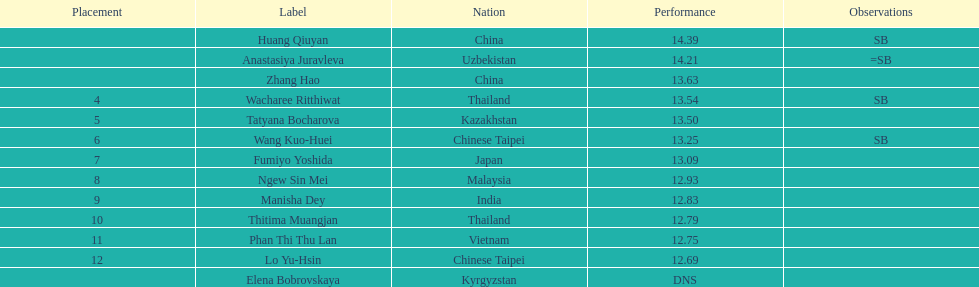Write the full table. {'header': ['Placement', 'Label', 'Nation', 'Performance', 'Observations'], 'rows': [['', 'Huang Qiuyan', 'China', '14.39', 'SB'], ['', 'Anastasiya Juravleva', 'Uzbekistan', '14.21', '=SB'], ['', 'Zhang Hao', 'China', '13.63', ''], ['4', 'Wacharee Ritthiwat', 'Thailand', '13.54', 'SB'], ['5', 'Tatyana Bocharova', 'Kazakhstan', '13.50', ''], ['6', 'Wang Kuo-Huei', 'Chinese Taipei', '13.25', 'SB'], ['7', 'Fumiyo Yoshida', 'Japan', '13.09', ''], ['8', 'Ngew Sin Mei', 'Malaysia', '12.93', ''], ['9', 'Manisha Dey', 'India', '12.83', ''], ['10', 'Thitima Muangjan', 'Thailand', '12.79', ''], ['11', 'Phan Thi Thu Lan', 'Vietnam', '12.75', ''], ['12', 'Lo Yu-Hsin', 'Chinese Taipei', '12.69', ''], ['', 'Elena Bobrovskaya', 'Kyrgyzstan', 'DNS', '']]} How many unique nationalities are represented among the top 5 athletes? 4. 